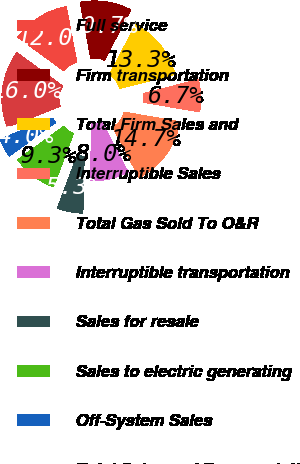<chart> <loc_0><loc_0><loc_500><loc_500><pie_chart><fcel>Full service<fcel>Firm transportation<fcel>Total Firm Sales and<fcel>Interruptible Sales<fcel>Total Gas Sold To O&R<fcel>Interruptible transportation<fcel>Sales for resale<fcel>Sales to electric generating<fcel>Off-System Sales<fcel>Total Sales and Transportation<nl><fcel>12.0%<fcel>10.67%<fcel>13.33%<fcel>6.67%<fcel>14.66%<fcel>8.0%<fcel>5.34%<fcel>9.33%<fcel>4.0%<fcel>16.0%<nl></chart> 